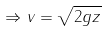<formula> <loc_0><loc_0><loc_500><loc_500>\Rightarrow v = \sqrt { 2 g z }</formula> 